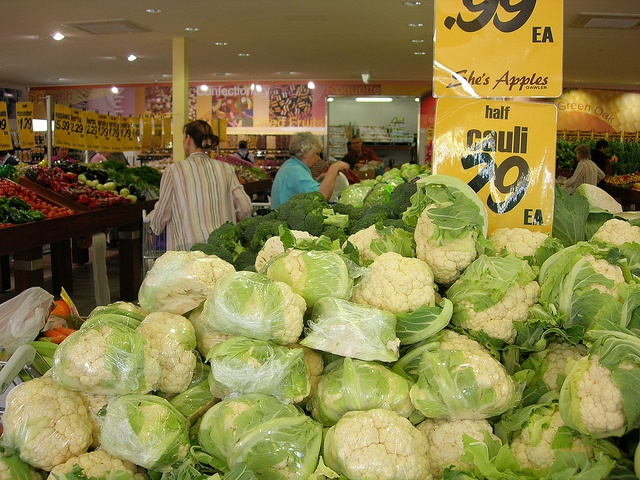Describe the objects in this image and their specific colors. I can see people in gray, tan, and darkgray tones, broccoli in gray, darkgreen, and olive tones, broccoli in gray, olive, khaki, and tan tones, people in gray, teal, and olive tones, and people in gray, olive, black, and maroon tones in this image. 